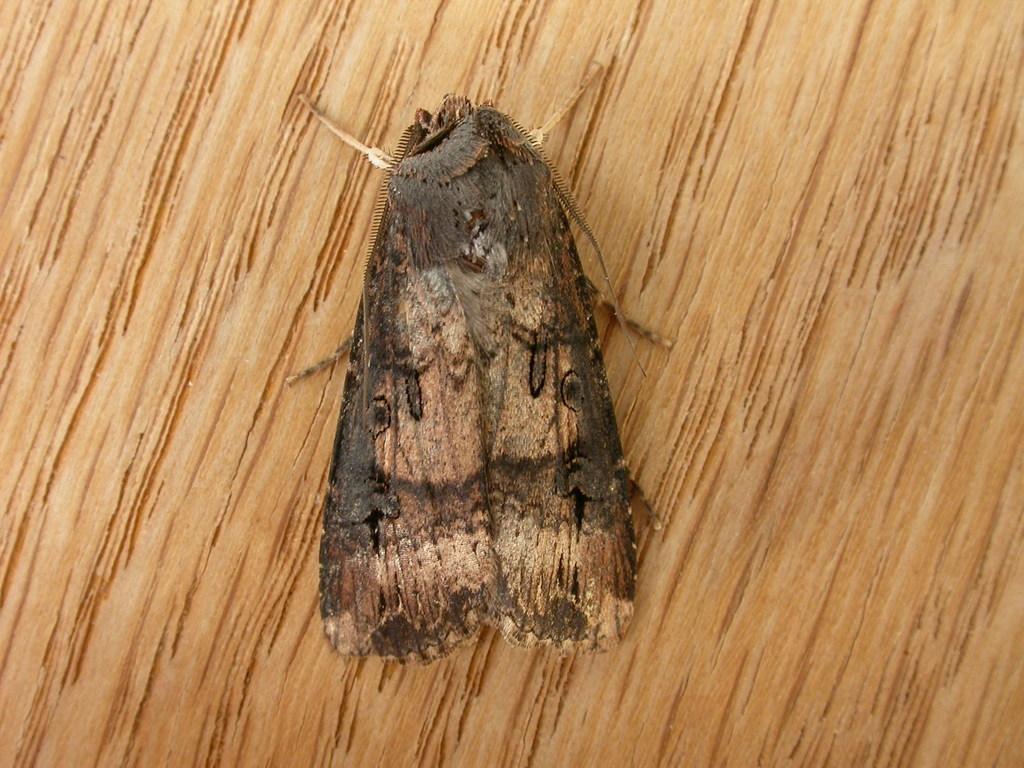Can you describe this image briefly? In this image we can see brown house moth on a wooden platform. 